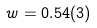Convert formula to latex. <formula><loc_0><loc_0><loc_500><loc_500>w = 0 . 5 4 ( 3 )</formula> 